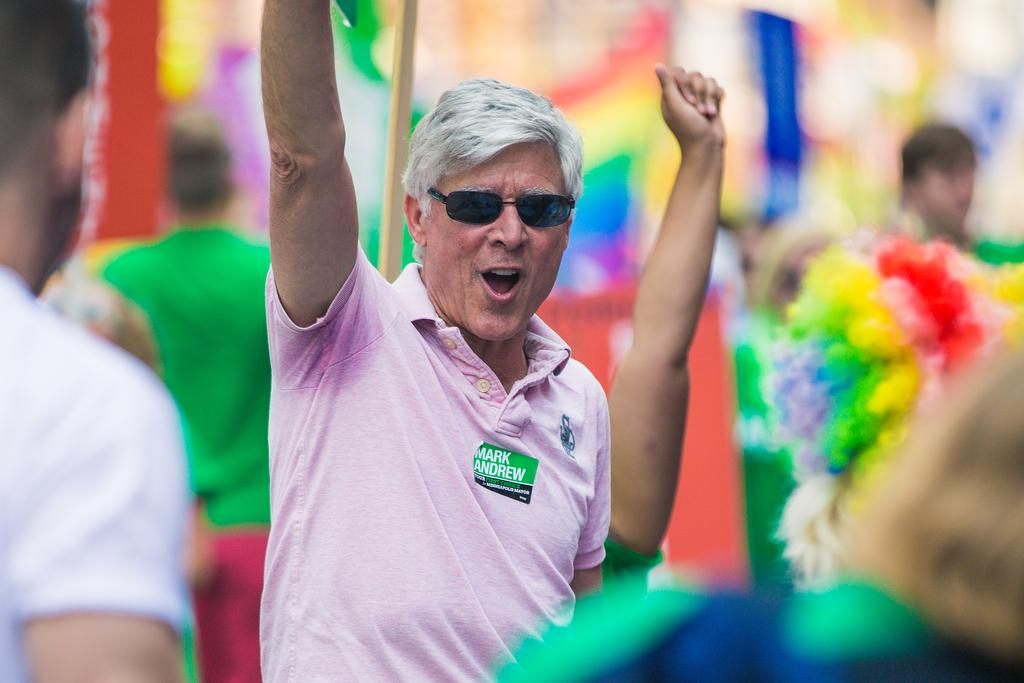What is the main subject of the image? The main subject of the image is a group of people. Can you describe the man in the middle of the group? The man in the middle of the group is wearing spectacles. How would you describe the background of the image? The background of the image is blurry. What shape is the wing of the bird in the image? There is no bird or wing present in the image; it features a group of people. How many rings is the person wearing on their finger in the image? There is no ring visible on any person's finger in the image. 